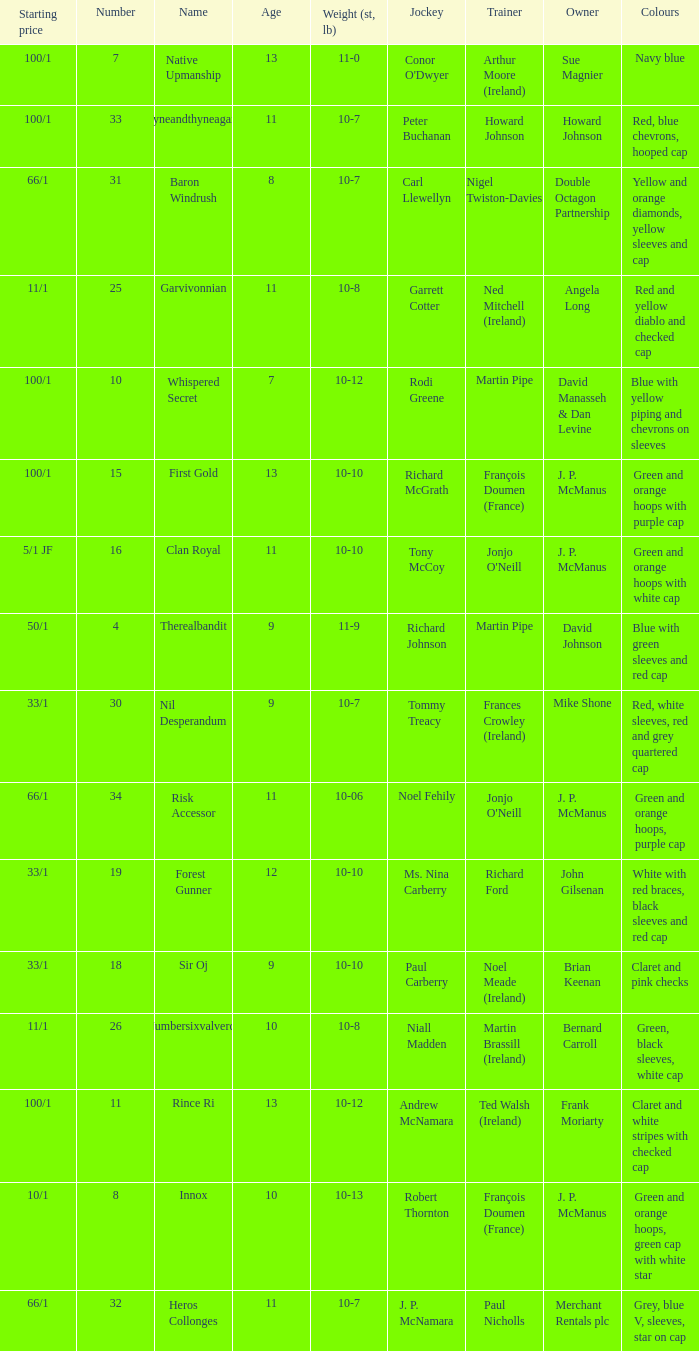How many age entries had a weight of 10-7 and an owner of Double Octagon Partnership? 1.0. Parse the full table. {'header': ['Starting price', 'Number', 'Name', 'Age', 'Weight (st, lb)', 'Jockey', 'Trainer', 'Owner', 'Colours'], 'rows': [['100/1', '7', 'Native Upmanship', '13', '11-0', "Conor O'Dwyer", 'Arthur Moore (Ireland)', 'Sue Magnier', 'Navy blue'], ['100/1', '33', 'Tyneandthyneagain', '11', '10-7', 'Peter Buchanan', 'Howard Johnson', 'Howard Johnson', 'Red, blue chevrons, hooped cap'], ['66/1', '31', 'Baron Windrush', '8', '10-7', 'Carl Llewellyn', 'Nigel Twiston-Davies', 'Double Octagon Partnership', 'Yellow and orange diamonds, yellow sleeves and cap'], ['11/1', '25', 'Garvivonnian', '11', '10-8', 'Garrett Cotter', 'Ned Mitchell (Ireland)', 'Angela Long', 'Red and yellow diablo and checked cap'], ['100/1', '10', 'Whispered Secret', '7', '10-12', 'Rodi Greene', 'Martin Pipe', 'David Manasseh & Dan Levine', 'Blue with yellow piping and chevrons on sleeves'], ['100/1', '15', 'First Gold', '13', '10-10', 'Richard McGrath', 'François Doumen (France)', 'J. P. McManus', 'Green and orange hoops with purple cap'], ['5/1 JF', '16', 'Clan Royal', '11', '10-10', 'Tony McCoy', "Jonjo O'Neill", 'J. P. McManus', 'Green and orange hoops with white cap'], ['50/1', '4', 'Therealbandit', '9', '11-9', 'Richard Johnson', 'Martin Pipe', 'David Johnson', 'Blue with green sleeves and red cap'], ['33/1', '30', 'Nil Desperandum', '9', '10-7', 'Tommy Treacy', 'Frances Crowley (Ireland)', 'Mike Shone', 'Red, white sleeves, red and grey quartered cap'], ['66/1', '34', 'Risk Accessor', '11', '10-06', 'Noel Fehily', "Jonjo O'Neill", 'J. P. McManus', 'Green and orange hoops, purple cap'], ['33/1', '19', 'Forest Gunner', '12', '10-10', 'Ms. Nina Carberry', 'Richard Ford', 'John Gilsenan', 'White with red braces, black sleeves and red cap'], ['33/1', '18', 'Sir Oj', '9', '10-10', 'Paul Carberry', 'Noel Meade (Ireland)', 'Brian Keenan', 'Claret and pink checks'], ['11/1', '26', 'Numbersixvalverde', '10', '10-8', 'Niall Madden', 'Martin Brassill (Ireland)', 'Bernard Carroll', 'Green, black sleeves, white cap'], ['100/1', '11', 'Rince Ri', '13', '10-12', 'Andrew McNamara', 'Ted Walsh (Ireland)', 'Frank Moriarty', 'Claret and white stripes with checked cap'], ['10/1', '8', 'Innox', '10', '10-13', 'Robert Thornton', 'François Doumen (France)', 'J. P. McManus', 'Green and orange hoops, green cap with white star'], ['66/1', '32', 'Heros Collonges', '11', '10-7', 'J. P. McNamara', 'Paul Nicholls', 'Merchant Rentals plc', 'Grey, blue V, sleeves, star on cap']]} 